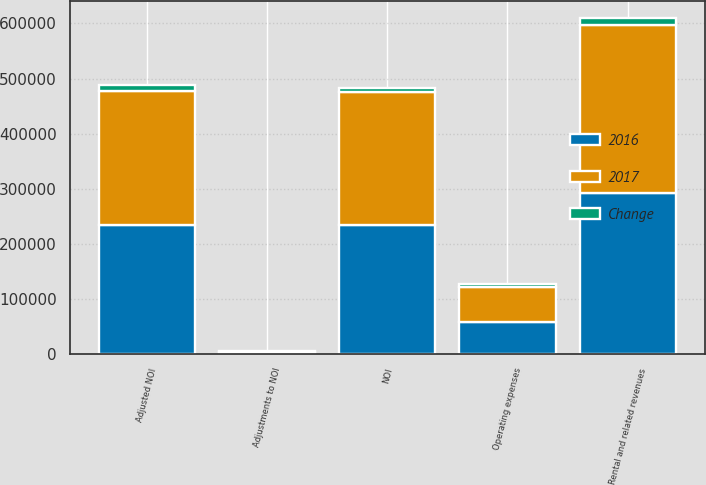Convert chart to OTSL. <chart><loc_0><loc_0><loc_500><loc_500><stacked_bar_chart><ecel><fcel>Rental and related revenues<fcel>Operating expenses<fcel>NOI<fcel>Adjustments to NOI<fcel>Adjusted NOI<nl><fcel>2017<fcel>304858<fcel>63612<fcel>241246<fcel>2427<fcel>243673<nl><fcel>2016<fcel>292147<fcel>58363<fcel>233784<fcel>339<fcel>234123<nl><fcel>Change<fcel>12711<fcel>5249<fcel>7462<fcel>2088<fcel>9550<nl></chart> 